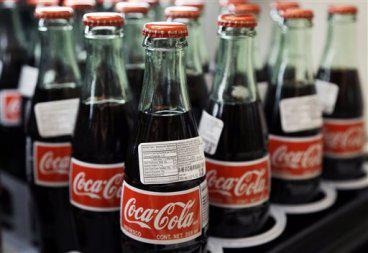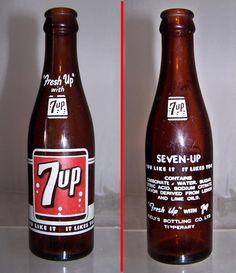The first image is the image on the left, the second image is the image on the right. For the images shown, is this caption "The left image shows a row of at least three different glass soda bottles, and the right image includes multiple filled plastic soda bottles with different labels." true? Answer yes or no. No. The first image is the image on the left, the second image is the image on the right. For the images shown, is this caption "Rows of red-capped cola bottles with red and white labels are in one image, all but one with a second white rectangular label on the neck." true? Answer yes or no. Yes. 